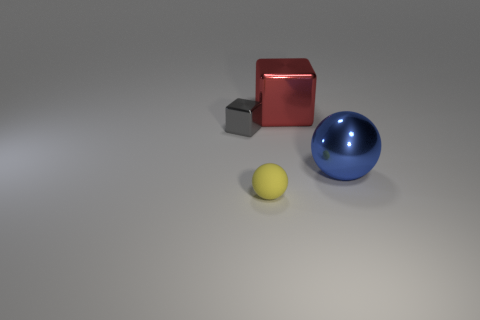Are there an equal number of metallic cubes in front of the yellow matte object and small gray blocks in front of the large shiny ball?
Keep it short and to the point. Yes. Are there any large spheres?
Make the answer very short. Yes. The other thing that is the same shape as the yellow thing is what size?
Provide a short and direct response. Large. There is a thing that is to the left of the yellow rubber thing; what is its size?
Offer a very short reply. Small. Are there more big shiny spheres that are in front of the blue object than small yellow matte balls?
Provide a succinct answer. No. What is the shape of the large blue metallic object?
Make the answer very short. Sphere. Do the shiny block behind the tiny metal block and the tiny thing in front of the big shiny sphere have the same color?
Your answer should be compact. No. Is the gray thing the same shape as the yellow object?
Provide a succinct answer. No. Is there anything else that is the same shape as the small yellow thing?
Ensure brevity in your answer.  Yes. Is the tiny object in front of the blue metal sphere made of the same material as the red block?
Keep it short and to the point. No. 